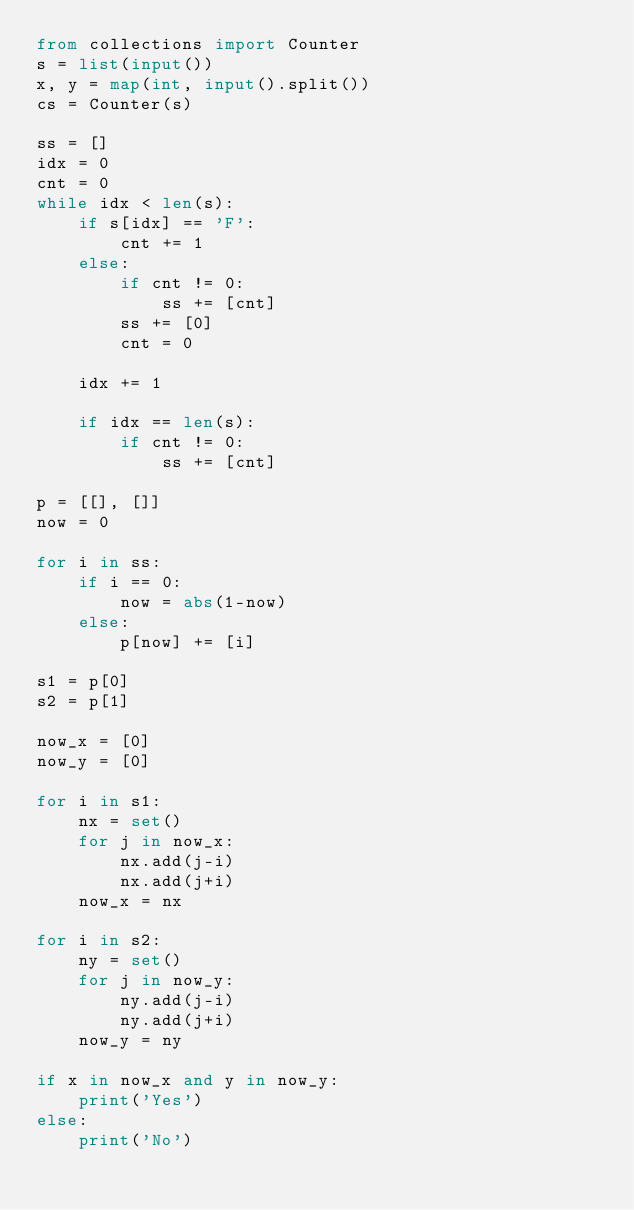<code> <loc_0><loc_0><loc_500><loc_500><_Python_>from collections import Counter
s = list(input())
x, y = map(int, input().split())
cs = Counter(s)

ss = []
idx = 0
cnt = 0
while idx < len(s):
    if s[idx] == 'F':
        cnt += 1
    else:
        if cnt != 0:
            ss += [cnt]
        ss += [0]
        cnt = 0

    idx += 1

    if idx == len(s):
        if cnt != 0:
            ss += [cnt]

p = [[], []]
now = 0

for i in ss:
    if i == 0:
        now = abs(1-now)
    else:
        p[now] += [i]

s1 = p[0]
s2 = p[1]

now_x = [0]
now_y = [0]

for i in s1:
    nx = set()
    for j in now_x:
        nx.add(j-i)
        nx.add(j+i)
    now_x = nx

for i in s2:
    ny = set()
    for j in now_y:
        ny.add(j-i)
        ny.add(j+i)
    now_y = ny

if x in now_x and y in now_y:
    print('Yes')
else:
    print('No')</code> 